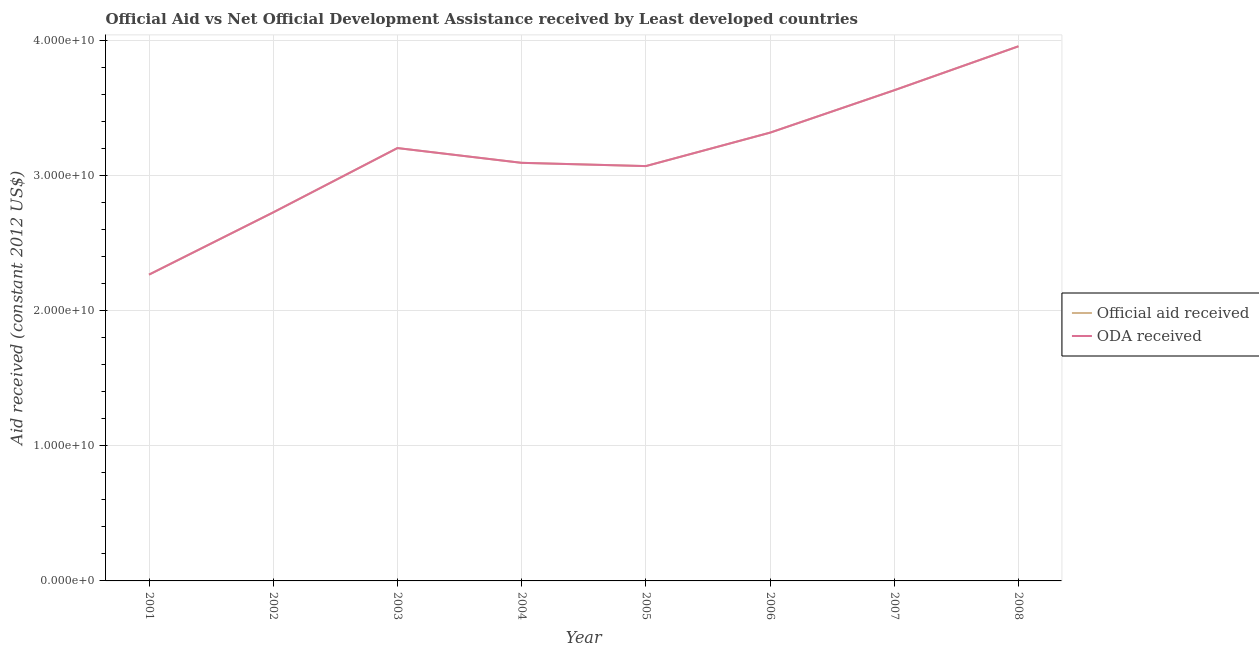How many different coloured lines are there?
Keep it short and to the point. 2. Does the line corresponding to oda received intersect with the line corresponding to official aid received?
Your response must be concise. Yes. What is the official aid received in 2003?
Keep it short and to the point. 3.20e+1. Across all years, what is the maximum oda received?
Offer a terse response. 3.96e+1. Across all years, what is the minimum official aid received?
Give a very brief answer. 2.27e+1. In which year was the oda received maximum?
Give a very brief answer. 2008. What is the total official aid received in the graph?
Keep it short and to the point. 2.53e+11. What is the difference between the official aid received in 2004 and that in 2008?
Offer a terse response. -8.63e+09. What is the difference between the oda received in 2002 and the official aid received in 2005?
Ensure brevity in your answer.  -3.43e+09. What is the average official aid received per year?
Offer a very short reply. 3.16e+1. What is the ratio of the oda received in 2001 to that in 2002?
Keep it short and to the point. 0.83. Is the oda received in 2006 less than that in 2007?
Your answer should be compact. Yes. What is the difference between the highest and the second highest official aid received?
Your answer should be very brief. 3.25e+09. What is the difference between the highest and the lowest oda received?
Provide a succinct answer. 1.69e+1. In how many years, is the oda received greater than the average oda received taken over all years?
Ensure brevity in your answer.  4. Is the sum of the official aid received in 2004 and 2005 greater than the maximum oda received across all years?
Offer a very short reply. Yes. Does the oda received monotonically increase over the years?
Offer a very short reply. No. How many years are there in the graph?
Offer a very short reply. 8. What is the difference between two consecutive major ticks on the Y-axis?
Give a very brief answer. 1.00e+1. Are the values on the major ticks of Y-axis written in scientific E-notation?
Your answer should be compact. Yes. Does the graph contain grids?
Provide a succinct answer. Yes. Where does the legend appear in the graph?
Your response must be concise. Center right. How are the legend labels stacked?
Give a very brief answer. Vertical. What is the title of the graph?
Offer a terse response. Official Aid vs Net Official Development Assistance received by Least developed countries . Does "Adolescent fertility rate" appear as one of the legend labels in the graph?
Keep it short and to the point. No. What is the label or title of the Y-axis?
Offer a very short reply. Aid received (constant 2012 US$). What is the Aid received (constant 2012 US$) of Official aid received in 2001?
Your answer should be very brief. 2.27e+1. What is the Aid received (constant 2012 US$) in ODA received in 2001?
Your response must be concise. 2.27e+1. What is the Aid received (constant 2012 US$) of Official aid received in 2002?
Your answer should be compact. 2.73e+1. What is the Aid received (constant 2012 US$) of ODA received in 2002?
Give a very brief answer. 2.73e+1. What is the Aid received (constant 2012 US$) of Official aid received in 2003?
Give a very brief answer. 3.20e+1. What is the Aid received (constant 2012 US$) of ODA received in 2003?
Keep it short and to the point. 3.20e+1. What is the Aid received (constant 2012 US$) of Official aid received in 2004?
Make the answer very short. 3.10e+1. What is the Aid received (constant 2012 US$) in ODA received in 2004?
Ensure brevity in your answer.  3.10e+1. What is the Aid received (constant 2012 US$) in Official aid received in 2005?
Give a very brief answer. 3.07e+1. What is the Aid received (constant 2012 US$) in ODA received in 2005?
Ensure brevity in your answer.  3.07e+1. What is the Aid received (constant 2012 US$) in Official aid received in 2006?
Ensure brevity in your answer.  3.32e+1. What is the Aid received (constant 2012 US$) in ODA received in 2006?
Offer a terse response. 3.32e+1. What is the Aid received (constant 2012 US$) in Official aid received in 2007?
Offer a very short reply. 3.63e+1. What is the Aid received (constant 2012 US$) of ODA received in 2007?
Your answer should be very brief. 3.63e+1. What is the Aid received (constant 2012 US$) of Official aid received in 2008?
Your answer should be compact. 3.96e+1. What is the Aid received (constant 2012 US$) of ODA received in 2008?
Make the answer very short. 3.96e+1. Across all years, what is the maximum Aid received (constant 2012 US$) in Official aid received?
Your answer should be compact. 3.96e+1. Across all years, what is the maximum Aid received (constant 2012 US$) of ODA received?
Make the answer very short. 3.96e+1. Across all years, what is the minimum Aid received (constant 2012 US$) of Official aid received?
Provide a short and direct response. 2.27e+1. Across all years, what is the minimum Aid received (constant 2012 US$) of ODA received?
Give a very brief answer. 2.27e+1. What is the total Aid received (constant 2012 US$) of Official aid received in the graph?
Provide a short and direct response. 2.53e+11. What is the total Aid received (constant 2012 US$) of ODA received in the graph?
Your answer should be very brief. 2.53e+11. What is the difference between the Aid received (constant 2012 US$) in Official aid received in 2001 and that in 2002?
Offer a terse response. -4.61e+09. What is the difference between the Aid received (constant 2012 US$) of ODA received in 2001 and that in 2002?
Ensure brevity in your answer.  -4.61e+09. What is the difference between the Aid received (constant 2012 US$) of Official aid received in 2001 and that in 2003?
Keep it short and to the point. -9.37e+09. What is the difference between the Aid received (constant 2012 US$) of ODA received in 2001 and that in 2003?
Provide a succinct answer. -9.37e+09. What is the difference between the Aid received (constant 2012 US$) of Official aid received in 2001 and that in 2004?
Offer a very short reply. -8.28e+09. What is the difference between the Aid received (constant 2012 US$) of ODA received in 2001 and that in 2004?
Make the answer very short. -8.28e+09. What is the difference between the Aid received (constant 2012 US$) in Official aid received in 2001 and that in 2005?
Provide a succinct answer. -8.04e+09. What is the difference between the Aid received (constant 2012 US$) in ODA received in 2001 and that in 2005?
Your answer should be very brief. -8.04e+09. What is the difference between the Aid received (constant 2012 US$) in Official aid received in 2001 and that in 2006?
Keep it short and to the point. -1.05e+1. What is the difference between the Aid received (constant 2012 US$) of ODA received in 2001 and that in 2006?
Your answer should be compact. -1.05e+1. What is the difference between the Aid received (constant 2012 US$) of Official aid received in 2001 and that in 2007?
Give a very brief answer. -1.37e+1. What is the difference between the Aid received (constant 2012 US$) of ODA received in 2001 and that in 2007?
Provide a succinct answer. -1.37e+1. What is the difference between the Aid received (constant 2012 US$) of Official aid received in 2001 and that in 2008?
Keep it short and to the point. -1.69e+1. What is the difference between the Aid received (constant 2012 US$) in ODA received in 2001 and that in 2008?
Make the answer very short. -1.69e+1. What is the difference between the Aid received (constant 2012 US$) of Official aid received in 2002 and that in 2003?
Keep it short and to the point. -4.76e+09. What is the difference between the Aid received (constant 2012 US$) in ODA received in 2002 and that in 2003?
Ensure brevity in your answer.  -4.76e+09. What is the difference between the Aid received (constant 2012 US$) of Official aid received in 2002 and that in 2004?
Your answer should be very brief. -3.67e+09. What is the difference between the Aid received (constant 2012 US$) of ODA received in 2002 and that in 2004?
Keep it short and to the point. -3.67e+09. What is the difference between the Aid received (constant 2012 US$) of Official aid received in 2002 and that in 2005?
Offer a terse response. -3.43e+09. What is the difference between the Aid received (constant 2012 US$) of ODA received in 2002 and that in 2005?
Your response must be concise. -3.43e+09. What is the difference between the Aid received (constant 2012 US$) of Official aid received in 2002 and that in 2006?
Offer a terse response. -5.90e+09. What is the difference between the Aid received (constant 2012 US$) in ODA received in 2002 and that in 2006?
Offer a terse response. -5.90e+09. What is the difference between the Aid received (constant 2012 US$) of Official aid received in 2002 and that in 2007?
Offer a terse response. -9.04e+09. What is the difference between the Aid received (constant 2012 US$) in ODA received in 2002 and that in 2007?
Provide a succinct answer. -9.04e+09. What is the difference between the Aid received (constant 2012 US$) in Official aid received in 2002 and that in 2008?
Offer a terse response. -1.23e+1. What is the difference between the Aid received (constant 2012 US$) in ODA received in 2002 and that in 2008?
Your response must be concise. -1.23e+1. What is the difference between the Aid received (constant 2012 US$) of Official aid received in 2003 and that in 2004?
Ensure brevity in your answer.  1.09e+09. What is the difference between the Aid received (constant 2012 US$) of ODA received in 2003 and that in 2004?
Keep it short and to the point. 1.09e+09. What is the difference between the Aid received (constant 2012 US$) in Official aid received in 2003 and that in 2005?
Your answer should be very brief. 1.33e+09. What is the difference between the Aid received (constant 2012 US$) in ODA received in 2003 and that in 2005?
Give a very brief answer. 1.33e+09. What is the difference between the Aid received (constant 2012 US$) of Official aid received in 2003 and that in 2006?
Offer a very short reply. -1.14e+09. What is the difference between the Aid received (constant 2012 US$) of ODA received in 2003 and that in 2006?
Make the answer very short. -1.14e+09. What is the difference between the Aid received (constant 2012 US$) of Official aid received in 2003 and that in 2007?
Your response must be concise. -4.28e+09. What is the difference between the Aid received (constant 2012 US$) of ODA received in 2003 and that in 2007?
Your answer should be very brief. -4.28e+09. What is the difference between the Aid received (constant 2012 US$) of Official aid received in 2003 and that in 2008?
Keep it short and to the point. -7.53e+09. What is the difference between the Aid received (constant 2012 US$) of ODA received in 2003 and that in 2008?
Ensure brevity in your answer.  -7.53e+09. What is the difference between the Aid received (constant 2012 US$) of Official aid received in 2004 and that in 2005?
Provide a succinct answer. 2.41e+08. What is the difference between the Aid received (constant 2012 US$) of ODA received in 2004 and that in 2005?
Your response must be concise. 2.41e+08. What is the difference between the Aid received (constant 2012 US$) of Official aid received in 2004 and that in 2006?
Make the answer very short. -2.23e+09. What is the difference between the Aid received (constant 2012 US$) in ODA received in 2004 and that in 2006?
Give a very brief answer. -2.23e+09. What is the difference between the Aid received (constant 2012 US$) of Official aid received in 2004 and that in 2007?
Keep it short and to the point. -5.37e+09. What is the difference between the Aid received (constant 2012 US$) of ODA received in 2004 and that in 2007?
Your response must be concise. -5.37e+09. What is the difference between the Aid received (constant 2012 US$) of Official aid received in 2004 and that in 2008?
Your response must be concise. -8.63e+09. What is the difference between the Aid received (constant 2012 US$) of ODA received in 2004 and that in 2008?
Make the answer very short. -8.63e+09. What is the difference between the Aid received (constant 2012 US$) of Official aid received in 2005 and that in 2006?
Provide a succinct answer. -2.47e+09. What is the difference between the Aid received (constant 2012 US$) in ODA received in 2005 and that in 2006?
Provide a succinct answer. -2.47e+09. What is the difference between the Aid received (constant 2012 US$) of Official aid received in 2005 and that in 2007?
Your answer should be compact. -5.62e+09. What is the difference between the Aid received (constant 2012 US$) in ODA received in 2005 and that in 2007?
Offer a very short reply. -5.62e+09. What is the difference between the Aid received (constant 2012 US$) in Official aid received in 2005 and that in 2008?
Your answer should be very brief. -8.87e+09. What is the difference between the Aid received (constant 2012 US$) of ODA received in 2005 and that in 2008?
Keep it short and to the point. -8.87e+09. What is the difference between the Aid received (constant 2012 US$) in Official aid received in 2006 and that in 2007?
Keep it short and to the point. -3.14e+09. What is the difference between the Aid received (constant 2012 US$) in ODA received in 2006 and that in 2007?
Your answer should be very brief. -3.14e+09. What is the difference between the Aid received (constant 2012 US$) in Official aid received in 2006 and that in 2008?
Ensure brevity in your answer.  -6.39e+09. What is the difference between the Aid received (constant 2012 US$) in ODA received in 2006 and that in 2008?
Keep it short and to the point. -6.39e+09. What is the difference between the Aid received (constant 2012 US$) of Official aid received in 2007 and that in 2008?
Your response must be concise. -3.25e+09. What is the difference between the Aid received (constant 2012 US$) of ODA received in 2007 and that in 2008?
Ensure brevity in your answer.  -3.25e+09. What is the difference between the Aid received (constant 2012 US$) of Official aid received in 2001 and the Aid received (constant 2012 US$) of ODA received in 2002?
Provide a short and direct response. -4.61e+09. What is the difference between the Aid received (constant 2012 US$) in Official aid received in 2001 and the Aid received (constant 2012 US$) in ODA received in 2003?
Provide a short and direct response. -9.37e+09. What is the difference between the Aid received (constant 2012 US$) of Official aid received in 2001 and the Aid received (constant 2012 US$) of ODA received in 2004?
Ensure brevity in your answer.  -8.28e+09. What is the difference between the Aid received (constant 2012 US$) in Official aid received in 2001 and the Aid received (constant 2012 US$) in ODA received in 2005?
Give a very brief answer. -8.04e+09. What is the difference between the Aid received (constant 2012 US$) in Official aid received in 2001 and the Aid received (constant 2012 US$) in ODA received in 2006?
Your answer should be very brief. -1.05e+1. What is the difference between the Aid received (constant 2012 US$) of Official aid received in 2001 and the Aid received (constant 2012 US$) of ODA received in 2007?
Offer a very short reply. -1.37e+1. What is the difference between the Aid received (constant 2012 US$) in Official aid received in 2001 and the Aid received (constant 2012 US$) in ODA received in 2008?
Offer a terse response. -1.69e+1. What is the difference between the Aid received (constant 2012 US$) of Official aid received in 2002 and the Aid received (constant 2012 US$) of ODA received in 2003?
Your response must be concise. -4.76e+09. What is the difference between the Aid received (constant 2012 US$) in Official aid received in 2002 and the Aid received (constant 2012 US$) in ODA received in 2004?
Keep it short and to the point. -3.67e+09. What is the difference between the Aid received (constant 2012 US$) in Official aid received in 2002 and the Aid received (constant 2012 US$) in ODA received in 2005?
Keep it short and to the point. -3.43e+09. What is the difference between the Aid received (constant 2012 US$) in Official aid received in 2002 and the Aid received (constant 2012 US$) in ODA received in 2006?
Make the answer very short. -5.90e+09. What is the difference between the Aid received (constant 2012 US$) of Official aid received in 2002 and the Aid received (constant 2012 US$) of ODA received in 2007?
Ensure brevity in your answer.  -9.04e+09. What is the difference between the Aid received (constant 2012 US$) in Official aid received in 2002 and the Aid received (constant 2012 US$) in ODA received in 2008?
Ensure brevity in your answer.  -1.23e+1. What is the difference between the Aid received (constant 2012 US$) in Official aid received in 2003 and the Aid received (constant 2012 US$) in ODA received in 2004?
Ensure brevity in your answer.  1.09e+09. What is the difference between the Aid received (constant 2012 US$) in Official aid received in 2003 and the Aid received (constant 2012 US$) in ODA received in 2005?
Your answer should be compact. 1.33e+09. What is the difference between the Aid received (constant 2012 US$) in Official aid received in 2003 and the Aid received (constant 2012 US$) in ODA received in 2006?
Keep it short and to the point. -1.14e+09. What is the difference between the Aid received (constant 2012 US$) of Official aid received in 2003 and the Aid received (constant 2012 US$) of ODA received in 2007?
Offer a terse response. -4.28e+09. What is the difference between the Aid received (constant 2012 US$) in Official aid received in 2003 and the Aid received (constant 2012 US$) in ODA received in 2008?
Provide a short and direct response. -7.53e+09. What is the difference between the Aid received (constant 2012 US$) of Official aid received in 2004 and the Aid received (constant 2012 US$) of ODA received in 2005?
Make the answer very short. 2.41e+08. What is the difference between the Aid received (constant 2012 US$) in Official aid received in 2004 and the Aid received (constant 2012 US$) in ODA received in 2006?
Offer a very short reply. -2.23e+09. What is the difference between the Aid received (constant 2012 US$) in Official aid received in 2004 and the Aid received (constant 2012 US$) in ODA received in 2007?
Your answer should be very brief. -5.37e+09. What is the difference between the Aid received (constant 2012 US$) of Official aid received in 2004 and the Aid received (constant 2012 US$) of ODA received in 2008?
Ensure brevity in your answer.  -8.63e+09. What is the difference between the Aid received (constant 2012 US$) of Official aid received in 2005 and the Aid received (constant 2012 US$) of ODA received in 2006?
Offer a very short reply. -2.47e+09. What is the difference between the Aid received (constant 2012 US$) in Official aid received in 2005 and the Aid received (constant 2012 US$) in ODA received in 2007?
Your answer should be compact. -5.62e+09. What is the difference between the Aid received (constant 2012 US$) of Official aid received in 2005 and the Aid received (constant 2012 US$) of ODA received in 2008?
Keep it short and to the point. -8.87e+09. What is the difference between the Aid received (constant 2012 US$) of Official aid received in 2006 and the Aid received (constant 2012 US$) of ODA received in 2007?
Offer a very short reply. -3.14e+09. What is the difference between the Aid received (constant 2012 US$) in Official aid received in 2006 and the Aid received (constant 2012 US$) in ODA received in 2008?
Your answer should be compact. -6.39e+09. What is the difference between the Aid received (constant 2012 US$) in Official aid received in 2007 and the Aid received (constant 2012 US$) in ODA received in 2008?
Give a very brief answer. -3.25e+09. What is the average Aid received (constant 2012 US$) in Official aid received per year?
Your response must be concise. 3.16e+1. What is the average Aid received (constant 2012 US$) in ODA received per year?
Your answer should be compact. 3.16e+1. In the year 2002, what is the difference between the Aid received (constant 2012 US$) in Official aid received and Aid received (constant 2012 US$) in ODA received?
Make the answer very short. 0. In the year 2003, what is the difference between the Aid received (constant 2012 US$) in Official aid received and Aid received (constant 2012 US$) in ODA received?
Give a very brief answer. 0. In the year 2004, what is the difference between the Aid received (constant 2012 US$) of Official aid received and Aid received (constant 2012 US$) of ODA received?
Your response must be concise. 0. In the year 2006, what is the difference between the Aid received (constant 2012 US$) of Official aid received and Aid received (constant 2012 US$) of ODA received?
Make the answer very short. 0. What is the ratio of the Aid received (constant 2012 US$) in Official aid received in 2001 to that in 2002?
Your response must be concise. 0.83. What is the ratio of the Aid received (constant 2012 US$) of ODA received in 2001 to that in 2002?
Ensure brevity in your answer.  0.83. What is the ratio of the Aid received (constant 2012 US$) in Official aid received in 2001 to that in 2003?
Provide a short and direct response. 0.71. What is the ratio of the Aid received (constant 2012 US$) in ODA received in 2001 to that in 2003?
Keep it short and to the point. 0.71. What is the ratio of the Aid received (constant 2012 US$) in Official aid received in 2001 to that in 2004?
Your answer should be very brief. 0.73. What is the ratio of the Aid received (constant 2012 US$) of ODA received in 2001 to that in 2004?
Give a very brief answer. 0.73. What is the ratio of the Aid received (constant 2012 US$) of Official aid received in 2001 to that in 2005?
Your response must be concise. 0.74. What is the ratio of the Aid received (constant 2012 US$) of ODA received in 2001 to that in 2005?
Provide a short and direct response. 0.74. What is the ratio of the Aid received (constant 2012 US$) in Official aid received in 2001 to that in 2006?
Provide a succinct answer. 0.68. What is the ratio of the Aid received (constant 2012 US$) of ODA received in 2001 to that in 2006?
Your answer should be compact. 0.68. What is the ratio of the Aid received (constant 2012 US$) in Official aid received in 2001 to that in 2007?
Offer a terse response. 0.62. What is the ratio of the Aid received (constant 2012 US$) of ODA received in 2001 to that in 2007?
Offer a very short reply. 0.62. What is the ratio of the Aid received (constant 2012 US$) of Official aid received in 2001 to that in 2008?
Make the answer very short. 0.57. What is the ratio of the Aid received (constant 2012 US$) of ODA received in 2001 to that in 2008?
Your answer should be very brief. 0.57. What is the ratio of the Aid received (constant 2012 US$) in Official aid received in 2002 to that in 2003?
Offer a terse response. 0.85. What is the ratio of the Aid received (constant 2012 US$) of ODA received in 2002 to that in 2003?
Ensure brevity in your answer.  0.85. What is the ratio of the Aid received (constant 2012 US$) in Official aid received in 2002 to that in 2004?
Provide a short and direct response. 0.88. What is the ratio of the Aid received (constant 2012 US$) in ODA received in 2002 to that in 2004?
Make the answer very short. 0.88. What is the ratio of the Aid received (constant 2012 US$) in Official aid received in 2002 to that in 2005?
Ensure brevity in your answer.  0.89. What is the ratio of the Aid received (constant 2012 US$) in ODA received in 2002 to that in 2005?
Offer a terse response. 0.89. What is the ratio of the Aid received (constant 2012 US$) of Official aid received in 2002 to that in 2006?
Provide a short and direct response. 0.82. What is the ratio of the Aid received (constant 2012 US$) of ODA received in 2002 to that in 2006?
Give a very brief answer. 0.82. What is the ratio of the Aid received (constant 2012 US$) in Official aid received in 2002 to that in 2007?
Ensure brevity in your answer.  0.75. What is the ratio of the Aid received (constant 2012 US$) in ODA received in 2002 to that in 2007?
Provide a succinct answer. 0.75. What is the ratio of the Aid received (constant 2012 US$) in Official aid received in 2002 to that in 2008?
Provide a short and direct response. 0.69. What is the ratio of the Aid received (constant 2012 US$) in ODA received in 2002 to that in 2008?
Your answer should be compact. 0.69. What is the ratio of the Aid received (constant 2012 US$) in Official aid received in 2003 to that in 2004?
Offer a very short reply. 1.04. What is the ratio of the Aid received (constant 2012 US$) in ODA received in 2003 to that in 2004?
Your answer should be very brief. 1.04. What is the ratio of the Aid received (constant 2012 US$) of Official aid received in 2003 to that in 2005?
Ensure brevity in your answer.  1.04. What is the ratio of the Aid received (constant 2012 US$) in ODA received in 2003 to that in 2005?
Offer a very short reply. 1.04. What is the ratio of the Aid received (constant 2012 US$) of Official aid received in 2003 to that in 2006?
Your response must be concise. 0.97. What is the ratio of the Aid received (constant 2012 US$) in ODA received in 2003 to that in 2006?
Keep it short and to the point. 0.97. What is the ratio of the Aid received (constant 2012 US$) of Official aid received in 2003 to that in 2007?
Provide a succinct answer. 0.88. What is the ratio of the Aid received (constant 2012 US$) of ODA received in 2003 to that in 2007?
Make the answer very short. 0.88. What is the ratio of the Aid received (constant 2012 US$) in Official aid received in 2003 to that in 2008?
Ensure brevity in your answer.  0.81. What is the ratio of the Aid received (constant 2012 US$) in ODA received in 2003 to that in 2008?
Offer a very short reply. 0.81. What is the ratio of the Aid received (constant 2012 US$) of Official aid received in 2004 to that in 2005?
Your answer should be very brief. 1.01. What is the ratio of the Aid received (constant 2012 US$) of ODA received in 2004 to that in 2005?
Offer a very short reply. 1.01. What is the ratio of the Aid received (constant 2012 US$) of Official aid received in 2004 to that in 2006?
Make the answer very short. 0.93. What is the ratio of the Aid received (constant 2012 US$) in ODA received in 2004 to that in 2006?
Your response must be concise. 0.93. What is the ratio of the Aid received (constant 2012 US$) in Official aid received in 2004 to that in 2007?
Your response must be concise. 0.85. What is the ratio of the Aid received (constant 2012 US$) in ODA received in 2004 to that in 2007?
Provide a succinct answer. 0.85. What is the ratio of the Aid received (constant 2012 US$) of Official aid received in 2004 to that in 2008?
Provide a succinct answer. 0.78. What is the ratio of the Aid received (constant 2012 US$) in ODA received in 2004 to that in 2008?
Your answer should be very brief. 0.78. What is the ratio of the Aid received (constant 2012 US$) in Official aid received in 2005 to that in 2006?
Your answer should be very brief. 0.93. What is the ratio of the Aid received (constant 2012 US$) in ODA received in 2005 to that in 2006?
Make the answer very short. 0.93. What is the ratio of the Aid received (constant 2012 US$) in Official aid received in 2005 to that in 2007?
Make the answer very short. 0.85. What is the ratio of the Aid received (constant 2012 US$) of ODA received in 2005 to that in 2007?
Keep it short and to the point. 0.85. What is the ratio of the Aid received (constant 2012 US$) of Official aid received in 2005 to that in 2008?
Provide a succinct answer. 0.78. What is the ratio of the Aid received (constant 2012 US$) of ODA received in 2005 to that in 2008?
Provide a short and direct response. 0.78. What is the ratio of the Aid received (constant 2012 US$) of Official aid received in 2006 to that in 2007?
Your answer should be very brief. 0.91. What is the ratio of the Aid received (constant 2012 US$) of ODA received in 2006 to that in 2007?
Keep it short and to the point. 0.91. What is the ratio of the Aid received (constant 2012 US$) in Official aid received in 2006 to that in 2008?
Provide a succinct answer. 0.84. What is the ratio of the Aid received (constant 2012 US$) in ODA received in 2006 to that in 2008?
Provide a succinct answer. 0.84. What is the ratio of the Aid received (constant 2012 US$) of Official aid received in 2007 to that in 2008?
Offer a very short reply. 0.92. What is the ratio of the Aid received (constant 2012 US$) in ODA received in 2007 to that in 2008?
Your answer should be very brief. 0.92. What is the difference between the highest and the second highest Aid received (constant 2012 US$) in Official aid received?
Give a very brief answer. 3.25e+09. What is the difference between the highest and the second highest Aid received (constant 2012 US$) of ODA received?
Offer a very short reply. 3.25e+09. What is the difference between the highest and the lowest Aid received (constant 2012 US$) in Official aid received?
Make the answer very short. 1.69e+1. What is the difference between the highest and the lowest Aid received (constant 2012 US$) in ODA received?
Ensure brevity in your answer.  1.69e+1. 